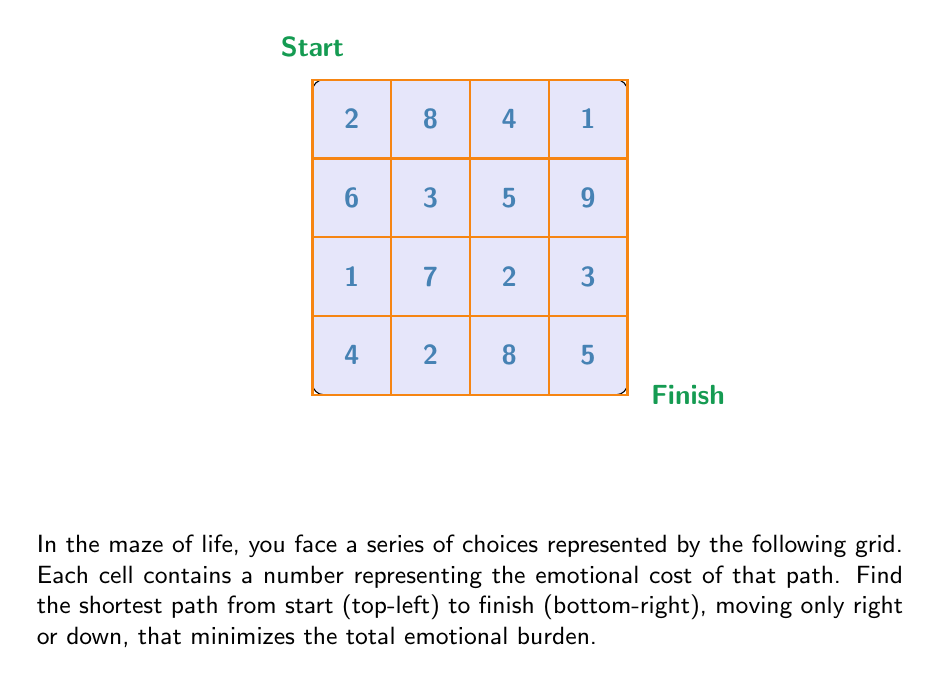Could you help me with this problem? To solve this problem, we'll use dynamic programming, which aligns with the idea of making choices in life that build upon previous decisions:

1) Create a matrix $$dp$$ of the same size as the input grid to store the minimum emotional cost to reach each cell.

2) Initialize the top-left cell of $$dp$$ with the value from the input grid:
   $$dp[0][0] = 2$$

3) Fill the first row and first column of $$dp$$:
   For first row: $$dp[0][j] = dp[0][j-1] + grid[0][j]$$
   For first column: $$dp[i][0] = dp[i-1][0] + grid[i][0]$$

4) Fill the rest of $$dp$$ using the recurrence relation:
   $$dp[i][j] = \min(dp[i-1][j], dp[i][j-1]) + grid[i][j]$$

5) The value in $$dp[3][3]$$ will give the minimum total emotional cost.

6) To find the path, backtrack from $$dp[3][3]$$ to $$dp[0][0]$$, always choosing the cell with the smaller value.

Filling the $$dp$$ matrix:

$$
\begin{array}{|c|c|c|c|}
\hline
2 & 10 & 14 & 15 \\
\hline
8 & 5 & 10 & 19 \\
\hline
9 & 12 & 7 & 10 \\
\hline
13 & 14 & 15 & 15 \\
\hline
\end{array}
$$

Backtracking the path: (3,3) → (2,3) → (2,2) → (1,2) → (1,1) → (0,1) → (0,0)

The path is: right → right → down → right → down → down
Answer: 15 